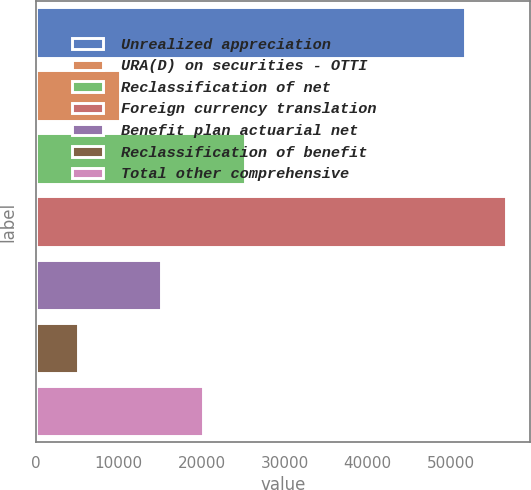Convert chart. <chart><loc_0><loc_0><loc_500><loc_500><bar_chart><fcel>Unrealized appreciation<fcel>URA(D) on securities - OTTI<fcel>Reclassification of net<fcel>Foreign currency translation<fcel>Benefit plan actuarial net<fcel>Reclassification of benefit<fcel>Total other comprehensive<nl><fcel>51684<fcel>10099.8<fcel>25180.2<fcel>56710.8<fcel>15126.6<fcel>5073<fcel>20153.4<nl></chart> 